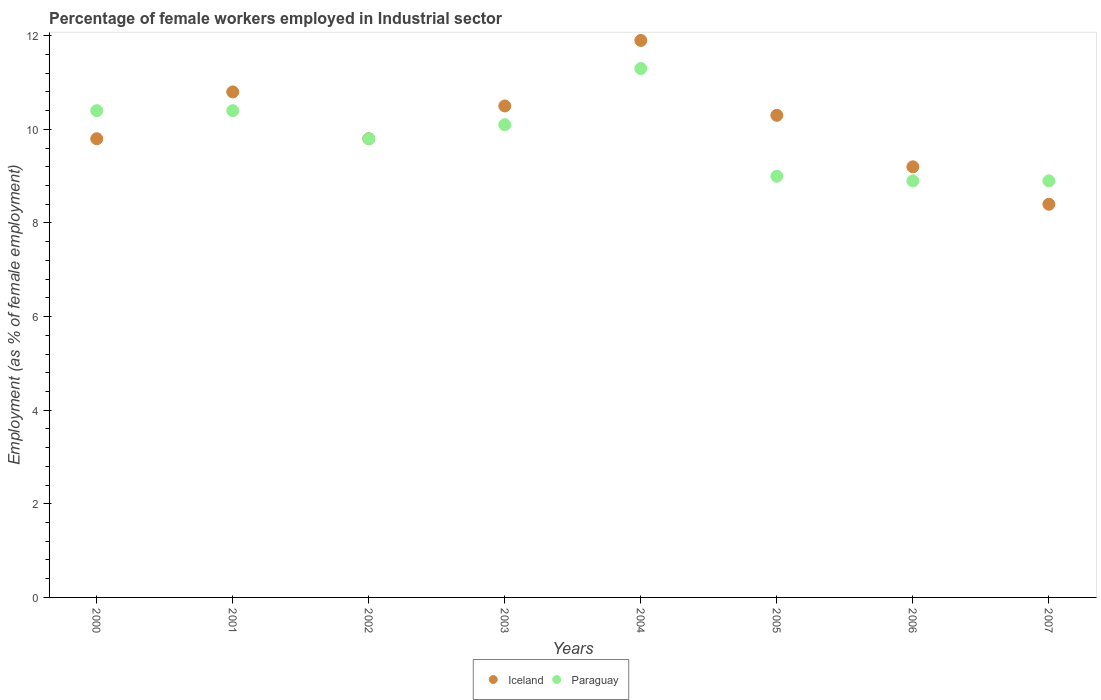Is the number of dotlines equal to the number of legend labels?
Your answer should be very brief. Yes. What is the percentage of females employed in Industrial sector in Iceland in 2005?
Keep it short and to the point. 10.3. Across all years, what is the maximum percentage of females employed in Industrial sector in Paraguay?
Ensure brevity in your answer.  11.3. Across all years, what is the minimum percentage of females employed in Industrial sector in Iceland?
Your response must be concise. 8.4. In which year was the percentage of females employed in Industrial sector in Iceland maximum?
Your response must be concise. 2004. What is the total percentage of females employed in Industrial sector in Iceland in the graph?
Keep it short and to the point. 80.7. What is the difference between the percentage of females employed in Industrial sector in Iceland in 2000 and that in 2002?
Your answer should be very brief. 0. What is the difference between the percentage of females employed in Industrial sector in Paraguay in 2006 and the percentage of females employed in Industrial sector in Iceland in 2003?
Provide a succinct answer. -1.6. What is the average percentage of females employed in Industrial sector in Paraguay per year?
Offer a very short reply. 9.85. What is the ratio of the percentage of females employed in Industrial sector in Iceland in 2006 to that in 2007?
Make the answer very short. 1.1. Is the percentage of females employed in Industrial sector in Iceland in 2000 less than that in 2001?
Your response must be concise. Yes. What is the difference between the highest and the second highest percentage of females employed in Industrial sector in Paraguay?
Give a very brief answer. 0.9. What is the difference between the highest and the lowest percentage of females employed in Industrial sector in Paraguay?
Give a very brief answer. 2.4. In how many years, is the percentage of females employed in Industrial sector in Paraguay greater than the average percentage of females employed in Industrial sector in Paraguay taken over all years?
Keep it short and to the point. 4. Is the sum of the percentage of females employed in Industrial sector in Iceland in 2002 and 2005 greater than the maximum percentage of females employed in Industrial sector in Paraguay across all years?
Offer a very short reply. Yes. Is the percentage of females employed in Industrial sector in Iceland strictly greater than the percentage of females employed in Industrial sector in Paraguay over the years?
Your response must be concise. No. How many years are there in the graph?
Give a very brief answer. 8. What is the difference between two consecutive major ticks on the Y-axis?
Keep it short and to the point. 2. How are the legend labels stacked?
Offer a terse response. Horizontal. What is the title of the graph?
Give a very brief answer. Percentage of female workers employed in Industrial sector. What is the label or title of the X-axis?
Ensure brevity in your answer.  Years. What is the label or title of the Y-axis?
Offer a very short reply. Employment (as % of female employment). What is the Employment (as % of female employment) of Iceland in 2000?
Offer a terse response. 9.8. What is the Employment (as % of female employment) in Paraguay in 2000?
Give a very brief answer. 10.4. What is the Employment (as % of female employment) in Iceland in 2001?
Ensure brevity in your answer.  10.8. What is the Employment (as % of female employment) in Paraguay in 2001?
Offer a terse response. 10.4. What is the Employment (as % of female employment) of Iceland in 2002?
Give a very brief answer. 9.8. What is the Employment (as % of female employment) in Paraguay in 2002?
Keep it short and to the point. 9.8. What is the Employment (as % of female employment) in Iceland in 2003?
Offer a very short reply. 10.5. What is the Employment (as % of female employment) in Paraguay in 2003?
Keep it short and to the point. 10.1. What is the Employment (as % of female employment) of Iceland in 2004?
Make the answer very short. 11.9. What is the Employment (as % of female employment) of Paraguay in 2004?
Offer a very short reply. 11.3. What is the Employment (as % of female employment) in Iceland in 2005?
Your answer should be very brief. 10.3. What is the Employment (as % of female employment) of Iceland in 2006?
Provide a succinct answer. 9.2. What is the Employment (as % of female employment) in Paraguay in 2006?
Offer a terse response. 8.9. What is the Employment (as % of female employment) in Iceland in 2007?
Offer a terse response. 8.4. What is the Employment (as % of female employment) in Paraguay in 2007?
Your answer should be compact. 8.9. Across all years, what is the maximum Employment (as % of female employment) of Iceland?
Provide a short and direct response. 11.9. Across all years, what is the maximum Employment (as % of female employment) of Paraguay?
Give a very brief answer. 11.3. Across all years, what is the minimum Employment (as % of female employment) of Iceland?
Your response must be concise. 8.4. Across all years, what is the minimum Employment (as % of female employment) of Paraguay?
Make the answer very short. 8.9. What is the total Employment (as % of female employment) in Iceland in the graph?
Give a very brief answer. 80.7. What is the total Employment (as % of female employment) in Paraguay in the graph?
Your answer should be compact. 78.8. What is the difference between the Employment (as % of female employment) in Paraguay in 2000 and that in 2001?
Offer a very short reply. 0. What is the difference between the Employment (as % of female employment) in Paraguay in 2000 and that in 2006?
Provide a succinct answer. 1.5. What is the difference between the Employment (as % of female employment) in Iceland in 2000 and that in 2007?
Your answer should be very brief. 1.4. What is the difference between the Employment (as % of female employment) of Iceland in 2001 and that in 2004?
Give a very brief answer. -1.1. What is the difference between the Employment (as % of female employment) in Iceland in 2001 and that in 2005?
Your response must be concise. 0.5. What is the difference between the Employment (as % of female employment) of Paraguay in 2001 and that in 2006?
Your answer should be very brief. 1.5. What is the difference between the Employment (as % of female employment) in Paraguay in 2002 and that in 2003?
Your answer should be very brief. -0.3. What is the difference between the Employment (as % of female employment) in Iceland in 2002 and that in 2004?
Offer a very short reply. -2.1. What is the difference between the Employment (as % of female employment) of Paraguay in 2002 and that in 2005?
Your answer should be very brief. 0.8. What is the difference between the Employment (as % of female employment) of Iceland in 2002 and that in 2006?
Offer a very short reply. 0.6. What is the difference between the Employment (as % of female employment) of Iceland in 2002 and that in 2007?
Ensure brevity in your answer.  1.4. What is the difference between the Employment (as % of female employment) of Paraguay in 2002 and that in 2007?
Give a very brief answer. 0.9. What is the difference between the Employment (as % of female employment) in Iceland in 2003 and that in 2004?
Provide a succinct answer. -1.4. What is the difference between the Employment (as % of female employment) in Paraguay in 2003 and that in 2004?
Your answer should be compact. -1.2. What is the difference between the Employment (as % of female employment) in Iceland in 2003 and that in 2005?
Your answer should be compact. 0.2. What is the difference between the Employment (as % of female employment) of Paraguay in 2003 and that in 2005?
Your answer should be compact. 1.1. What is the difference between the Employment (as % of female employment) of Iceland in 2003 and that in 2006?
Your response must be concise. 1.3. What is the difference between the Employment (as % of female employment) of Paraguay in 2003 and that in 2006?
Offer a very short reply. 1.2. What is the difference between the Employment (as % of female employment) of Iceland in 2003 and that in 2007?
Provide a short and direct response. 2.1. What is the difference between the Employment (as % of female employment) in Paraguay in 2003 and that in 2007?
Your answer should be compact. 1.2. What is the difference between the Employment (as % of female employment) of Iceland in 2004 and that in 2005?
Make the answer very short. 1.6. What is the difference between the Employment (as % of female employment) of Iceland in 2004 and that in 2006?
Your answer should be compact. 2.7. What is the difference between the Employment (as % of female employment) of Iceland in 2005 and that in 2007?
Make the answer very short. 1.9. What is the difference between the Employment (as % of female employment) in Iceland in 2000 and the Employment (as % of female employment) in Paraguay in 2001?
Give a very brief answer. -0.6. What is the difference between the Employment (as % of female employment) of Iceland in 2000 and the Employment (as % of female employment) of Paraguay in 2002?
Offer a terse response. 0. What is the difference between the Employment (as % of female employment) of Iceland in 2000 and the Employment (as % of female employment) of Paraguay in 2007?
Provide a succinct answer. 0.9. What is the difference between the Employment (as % of female employment) of Iceland in 2001 and the Employment (as % of female employment) of Paraguay in 2002?
Your response must be concise. 1. What is the difference between the Employment (as % of female employment) in Iceland in 2001 and the Employment (as % of female employment) in Paraguay in 2006?
Offer a terse response. 1.9. What is the difference between the Employment (as % of female employment) in Iceland in 2002 and the Employment (as % of female employment) in Paraguay in 2005?
Your response must be concise. 0.8. What is the difference between the Employment (as % of female employment) in Iceland in 2003 and the Employment (as % of female employment) in Paraguay in 2004?
Your answer should be compact. -0.8. What is the difference between the Employment (as % of female employment) in Iceland in 2003 and the Employment (as % of female employment) in Paraguay in 2005?
Make the answer very short. 1.5. What is the difference between the Employment (as % of female employment) of Iceland in 2003 and the Employment (as % of female employment) of Paraguay in 2006?
Your response must be concise. 1.6. What is the difference between the Employment (as % of female employment) in Iceland in 2006 and the Employment (as % of female employment) in Paraguay in 2007?
Provide a succinct answer. 0.3. What is the average Employment (as % of female employment) in Iceland per year?
Your answer should be very brief. 10.09. What is the average Employment (as % of female employment) of Paraguay per year?
Provide a succinct answer. 9.85. In the year 2000, what is the difference between the Employment (as % of female employment) of Iceland and Employment (as % of female employment) of Paraguay?
Ensure brevity in your answer.  -0.6. In the year 2001, what is the difference between the Employment (as % of female employment) of Iceland and Employment (as % of female employment) of Paraguay?
Make the answer very short. 0.4. In the year 2002, what is the difference between the Employment (as % of female employment) in Iceland and Employment (as % of female employment) in Paraguay?
Your answer should be compact. 0. In the year 2003, what is the difference between the Employment (as % of female employment) in Iceland and Employment (as % of female employment) in Paraguay?
Give a very brief answer. 0.4. In the year 2004, what is the difference between the Employment (as % of female employment) of Iceland and Employment (as % of female employment) of Paraguay?
Your answer should be very brief. 0.6. In the year 2005, what is the difference between the Employment (as % of female employment) in Iceland and Employment (as % of female employment) in Paraguay?
Your answer should be very brief. 1.3. In the year 2007, what is the difference between the Employment (as % of female employment) of Iceland and Employment (as % of female employment) of Paraguay?
Provide a short and direct response. -0.5. What is the ratio of the Employment (as % of female employment) of Iceland in 2000 to that in 2001?
Ensure brevity in your answer.  0.91. What is the ratio of the Employment (as % of female employment) of Paraguay in 2000 to that in 2001?
Your answer should be very brief. 1. What is the ratio of the Employment (as % of female employment) in Iceland in 2000 to that in 2002?
Make the answer very short. 1. What is the ratio of the Employment (as % of female employment) of Paraguay in 2000 to that in 2002?
Ensure brevity in your answer.  1.06. What is the ratio of the Employment (as % of female employment) of Paraguay in 2000 to that in 2003?
Provide a succinct answer. 1.03. What is the ratio of the Employment (as % of female employment) of Iceland in 2000 to that in 2004?
Offer a very short reply. 0.82. What is the ratio of the Employment (as % of female employment) of Paraguay in 2000 to that in 2004?
Make the answer very short. 0.92. What is the ratio of the Employment (as % of female employment) of Iceland in 2000 to that in 2005?
Offer a terse response. 0.95. What is the ratio of the Employment (as % of female employment) in Paraguay in 2000 to that in 2005?
Your response must be concise. 1.16. What is the ratio of the Employment (as % of female employment) of Iceland in 2000 to that in 2006?
Offer a terse response. 1.07. What is the ratio of the Employment (as % of female employment) in Paraguay in 2000 to that in 2006?
Make the answer very short. 1.17. What is the ratio of the Employment (as % of female employment) in Iceland in 2000 to that in 2007?
Provide a succinct answer. 1.17. What is the ratio of the Employment (as % of female employment) of Paraguay in 2000 to that in 2007?
Ensure brevity in your answer.  1.17. What is the ratio of the Employment (as % of female employment) of Iceland in 2001 to that in 2002?
Give a very brief answer. 1.1. What is the ratio of the Employment (as % of female employment) of Paraguay in 2001 to that in 2002?
Give a very brief answer. 1.06. What is the ratio of the Employment (as % of female employment) in Iceland in 2001 to that in 2003?
Your answer should be compact. 1.03. What is the ratio of the Employment (as % of female employment) of Paraguay in 2001 to that in 2003?
Provide a short and direct response. 1.03. What is the ratio of the Employment (as % of female employment) of Iceland in 2001 to that in 2004?
Provide a short and direct response. 0.91. What is the ratio of the Employment (as % of female employment) in Paraguay in 2001 to that in 2004?
Your answer should be compact. 0.92. What is the ratio of the Employment (as % of female employment) of Iceland in 2001 to that in 2005?
Provide a short and direct response. 1.05. What is the ratio of the Employment (as % of female employment) in Paraguay in 2001 to that in 2005?
Provide a short and direct response. 1.16. What is the ratio of the Employment (as % of female employment) in Iceland in 2001 to that in 2006?
Give a very brief answer. 1.17. What is the ratio of the Employment (as % of female employment) in Paraguay in 2001 to that in 2006?
Provide a short and direct response. 1.17. What is the ratio of the Employment (as % of female employment) of Iceland in 2001 to that in 2007?
Offer a very short reply. 1.29. What is the ratio of the Employment (as % of female employment) of Paraguay in 2001 to that in 2007?
Keep it short and to the point. 1.17. What is the ratio of the Employment (as % of female employment) of Paraguay in 2002 to that in 2003?
Make the answer very short. 0.97. What is the ratio of the Employment (as % of female employment) in Iceland in 2002 to that in 2004?
Offer a terse response. 0.82. What is the ratio of the Employment (as % of female employment) in Paraguay in 2002 to that in 2004?
Give a very brief answer. 0.87. What is the ratio of the Employment (as % of female employment) of Iceland in 2002 to that in 2005?
Keep it short and to the point. 0.95. What is the ratio of the Employment (as % of female employment) in Paraguay in 2002 to that in 2005?
Your response must be concise. 1.09. What is the ratio of the Employment (as % of female employment) in Iceland in 2002 to that in 2006?
Provide a succinct answer. 1.07. What is the ratio of the Employment (as % of female employment) of Paraguay in 2002 to that in 2006?
Provide a succinct answer. 1.1. What is the ratio of the Employment (as % of female employment) of Iceland in 2002 to that in 2007?
Provide a short and direct response. 1.17. What is the ratio of the Employment (as % of female employment) in Paraguay in 2002 to that in 2007?
Offer a terse response. 1.1. What is the ratio of the Employment (as % of female employment) in Iceland in 2003 to that in 2004?
Give a very brief answer. 0.88. What is the ratio of the Employment (as % of female employment) of Paraguay in 2003 to that in 2004?
Your response must be concise. 0.89. What is the ratio of the Employment (as % of female employment) in Iceland in 2003 to that in 2005?
Offer a terse response. 1.02. What is the ratio of the Employment (as % of female employment) of Paraguay in 2003 to that in 2005?
Keep it short and to the point. 1.12. What is the ratio of the Employment (as % of female employment) in Iceland in 2003 to that in 2006?
Keep it short and to the point. 1.14. What is the ratio of the Employment (as % of female employment) in Paraguay in 2003 to that in 2006?
Your answer should be compact. 1.13. What is the ratio of the Employment (as % of female employment) in Paraguay in 2003 to that in 2007?
Offer a terse response. 1.13. What is the ratio of the Employment (as % of female employment) of Iceland in 2004 to that in 2005?
Your answer should be very brief. 1.16. What is the ratio of the Employment (as % of female employment) in Paraguay in 2004 to that in 2005?
Offer a very short reply. 1.26. What is the ratio of the Employment (as % of female employment) of Iceland in 2004 to that in 2006?
Your answer should be compact. 1.29. What is the ratio of the Employment (as % of female employment) in Paraguay in 2004 to that in 2006?
Offer a very short reply. 1.27. What is the ratio of the Employment (as % of female employment) of Iceland in 2004 to that in 2007?
Ensure brevity in your answer.  1.42. What is the ratio of the Employment (as % of female employment) of Paraguay in 2004 to that in 2007?
Make the answer very short. 1.27. What is the ratio of the Employment (as % of female employment) in Iceland in 2005 to that in 2006?
Ensure brevity in your answer.  1.12. What is the ratio of the Employment (as % of female employment) of Paraguay in 2005 to that in 2006?
Provide a short and direct response. 1.01. What is the ratio of the Employment (as % of female employment) in Iceland in 2005 to that in 2007?
Offer a terse response. 1.23. What is the ratio of the Employment (as % of female employment) in Paraguay in 2005 to that in 2007?
Give a very brief answer. 1.01. What is the ratio of the Employment (as % of female employment) in Iceland in 2006 to that in 2007?
Provide a succinct answer. 1.1. What is the ratio of the Employment (as % of female employment) of Paraguay in 2006 to that in 2007?
Provide a short and direct response. 1. What is the difference between the highest and the second highest Employment (as % of female employment) of Iceland?
Offer a terse response. 1.1. What is the difference between the highest and the lowest Employment (as % of female employment) in Iceland?
Your answer should be very brief. 3.5. What is the difference between the highest and the lowest Employment (as % of female employment) in Paraguay?
Ensure brevity in your answer.  2.4. 